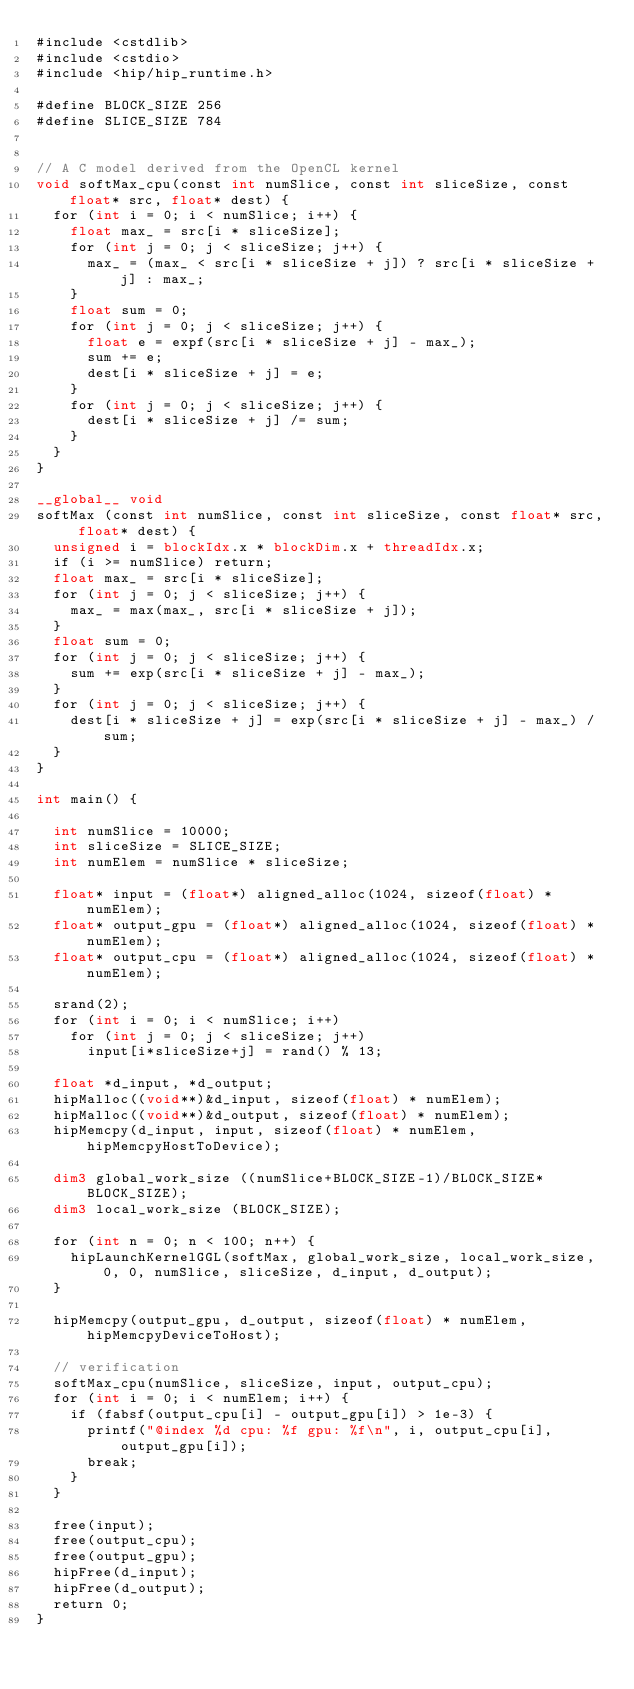Convert code to text. <code><loc_0><loc_0><loc_500><loc_500><_Cuda_>#include <cstdlib>
#include <cstdio>
#include <hip/hip_runtime.h>

#define BLOCK_SIZE 256
#define SLICE_SIZE 784


// A C model derived from the OpenCL kernel 
void softMax_cpu(const int numSlice, const int sliceSize, const float* src, float* dest) {
  for (int i = 0; i < numSlice; i++) {
    float max_ = src[i * sliceSize];
    for (int j = 0; j < sliceSize; j++) {
      max_ = (max_ < src[i * sliceSize + j]) ? src[i * sliceSize + j] : max_;
    }
    float sum = 0;
    for (int j = 0; j < sliceSize; j++) {
      float e = expf(src[i * sliceSize + j] - max_);
      sum += e;
      dest[i * sliceSize + j] = e;
    }
    for (int j = 0; j < sliceSize; j++) {
      dest[i * sliceSize + j] /= sum;
    }
  }
}

__global__ void 
softMax (const int numSlice, const int sliceSize, const float* src, float* dest) {
  unsigned i = blockIdx.x * blockDim.x + threadIdx.x;
  if (i >= numSlice) return;
  float max_ = src[i * sliceSize];
  for (int j = 0; j < sliceSize; j++) {
    max_ = max(max_, src[i * sliceSize + j]);
  }
  float sum = 0;
  for (int j = 0; j < sliceSize; j++) {
    sum += exp(src[i * sliceSize + j] - max_);
  }
  for (int j = 0; j < sliceSize; j++) {
    dest[i * sliceSize + j] = exp(src[i * sliceSize + j] - max_) / sum;
  }
}

int main() {
   
  int numSlice = 10000;
  int sliceSize = SLICE_SIZE;
  int numElem = numSlice * sliceSize;

  float* input = (float*) aligned_alloc(1024, sizeof(float) * numElem);
  float* output_gpu = (float*) aligned_alloc(1024, sizeof(float) * numElem);
  float* output_cpu = (float*) aligned_alloc(1024, sizeof(float) * numElem);

  srand(2);
  for (int i = 0; i < numSlice; i++)
    for (int j = 0; j < sliceSize; j++)
      input[i*sliceSize+j] = rand() % 13; 

  float *d_input, *d_output;
  hipMalloc((void**)&d_input, sizeof(float) * numElem);
  hipMalloc((void**)&d_output, sizeof(float) * numElem);
  hipMemcpy(d_input, input, sizeof(float) * numElem, hipMemcpyHostToDevice);

  dim3 global_work_size ((numSlice+BLOCK_SIZE-1)/BLOCK_SIZE*BLOCK_SIZE);
  dim3 local_work_size (BLOCK_SIZE);

  for (int n = 0; n < 100; n++) {
    hipLaunchKernelGGL(softMax, global_work_size, local_work_size, 0, 0, numSlice, sliceSize, d_input, d_output);
  }

  hipMemcpy(output_gpu, d_output, sizeof(float) * numElem, hipMemcpyDeviceToHost);

  // verification
  softMax_cpu(numSlice, sliceSize, input, output_cpu);
  for (int i = 0; i < numElem; i++) {
    if (fabsf(output_cpu[i] - output_gpu[i]) > 1e-3) {
      printf("@index %d cpu: %f gpu: %f\n", i, output_cpu[i], output_gpu[i]);
      break;
    }
  }

  free(input);
  free(output_cpu);
  free(output_gpu);
  hipFree(d_input);
  hipFree(d_output);
  return 0;
}

</code> 